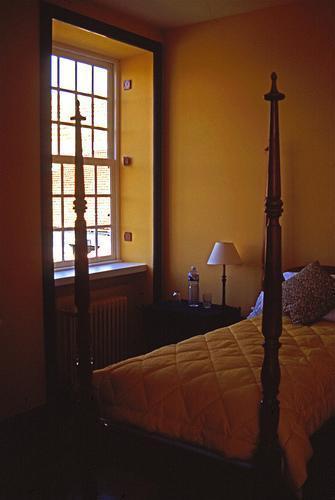How many beds are shown in the picture?
Give a very brief answer. 1. 